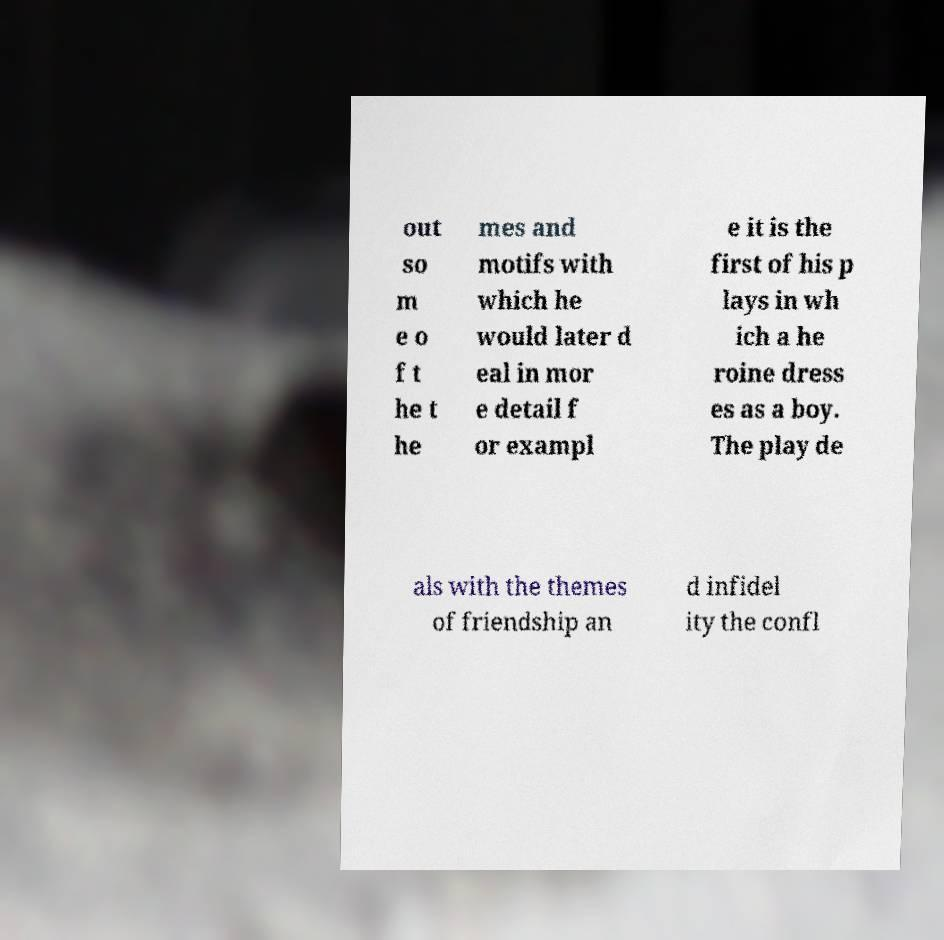I need the written content from this picture converted into text. Can you do that? out so m e o f t he t he mes and motifs with which he would later d eal in mor e detail f or exampl e it is the first of his p lays in wh ich a he roine dress es as a boy. The play de als with the themes of friendship an d infidel ity the confl 